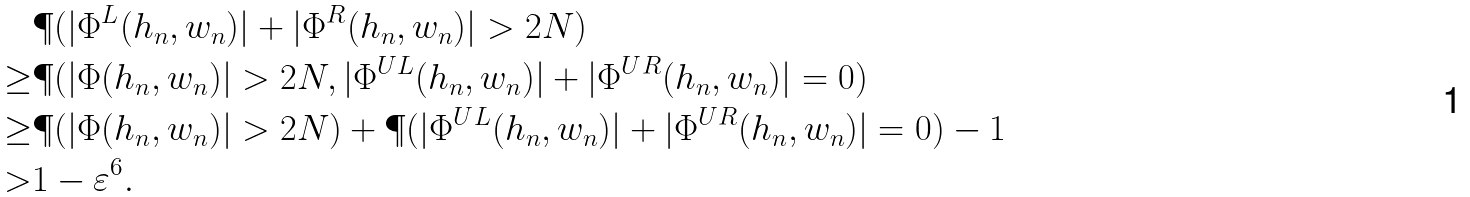<formula> <loc_0><loc_0><loc_500><loc_500>& \P ( | \Phi ^ { L } ( h _ { n } , w _ { n } ) | + | \Phi ^ { R } ( h _ { n } , w _ { n } ) | > 2 N ) \\ \geq & \P ( | \Phi ( h _ { n } , w _ { n } ) | > 2 N , | \Phi ^ { U L } ( h _ { n } , w _ { n } ) | + | \Phi ^ { U R } ( h _ { n } , w _ { n } ) | = 0 ) \\ \geq & \P ( | \Phi ( h _ { n } , w _ { n } ) | > 2 N ) + \P ( | \Phi ^ { U L } ( h _ { n } , w _ { n } ) | + | \Phi ^ { U R } ( h _ { n } , w _ { n } ) | = 0 ) - 1 \\ > & 1 - \varepsilon ^ { 6 } .</formula> 